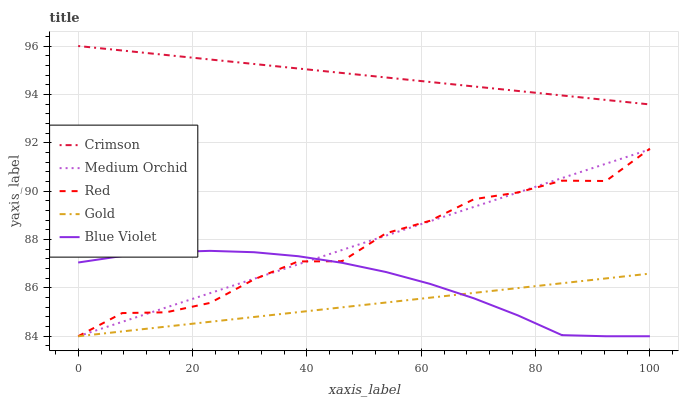Does Gold have the minimum area under the curve?
Answer yes or no. Yes. Does Crimson have the maximum area under the curve?
Answer yes or no. Yes. Does Blue Violet have the minimum area under the curve?
Answer yes or no. No. Does Blue Violet have the maximum area under the curve?
Answer yes or no. No. Is Gold the smoothest?
Answer yes or no. Yes. Is Red the roughest?
Answer yes or no. Yes. Is Blue Violet the smoothest?
Answer yes or no. No. Is Blue Violet the roughest?
Answer yes or no. No. Does Blue Violet have the lowest value?
Answer yes or no. Yes. Does Crimson have the highest value?
Answer yes or no. Yes. Does Blue Violet have the highest value?
Answer yes or no. No. Is Medium Orchid less than Crimson?
Answer yes or no. Yes. Is Crimson greater than Gold?
Answer yes or no. Yes. Does Medium Orchid intersect Gold?
Answer yes or no. Yes. Is Medium Orchid less than Gold?
Answer yes or no. No. Is Medium Orchid greater than Gold?
Answer yes or no. No. Does Medium Orchid intersect Crimson?
Answer yes or no. No. 